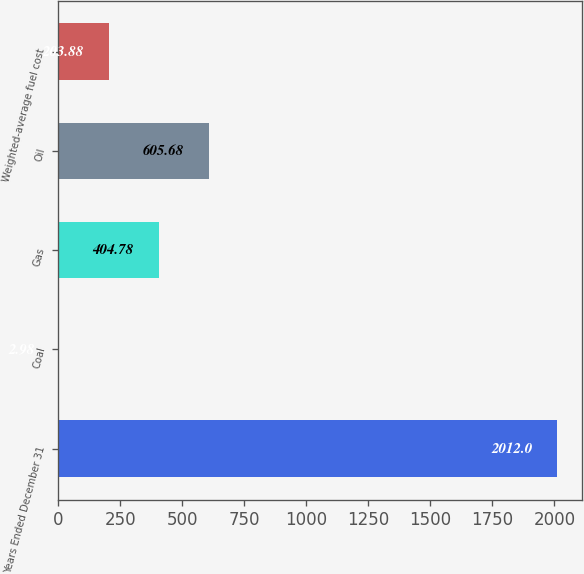Convert chart. <chart><loc_0><loc_0><loc_500><loc_500><bar_chart><fcel>Years Ended December 31<fcel>Coal<fcel>Gas<fcel>Oil<fcel>Weighted-average fuel cost<nl><fcel>2012<fcel>2.98<fcel>404.78<fcel>605.68<fcel>203.88<nl></chart> 